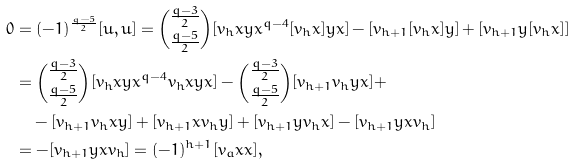Convert formula to latex. <formula><loc_0><loc_0><loc_500><loc_500>0 & = ( - 1 ) ^ { \frac { q - 5 } { 2 } } [ u , u ] = \binom { \frac { q - 3 } { 2 } } { \frac { q - 5 } { 2 } } [ v _ { h } x y x ^ { q - 4 } [ v _ { h } x ] y x ] - [ v _ { h + 1 } [ v _ { h } x ] y ] + [ v _ { h + 1 } y [ v _ { h } x ] ] \\ & = \binom { \frac { q - 3 } { 2 } } { \frac { q - 5 } { 2 } } [ v _ { h } x y x ^ { q - 4 } v _ { h } x y x ] - \binom { \frac { q - 3 } { 2 } } { \frac { q - 5 } { 2 } } [ v _ { h + 1 } v _ { h } y x ] + \\ & \quad - [ v _ { h + 1 } v _ { h } x y ] + [ v _ { h + 1 } x v _ { h } y ] + [ v _ { h + 1 } y v _ { h } x ] - [ v _ { h + 1 } y x v _ { h } ] \\ & = - [ v _ { h + 1 } y x v _ { h } ] = ( - 1 ) ^ { h + 1 } [ v _ { a } x x ] ,</formula> 